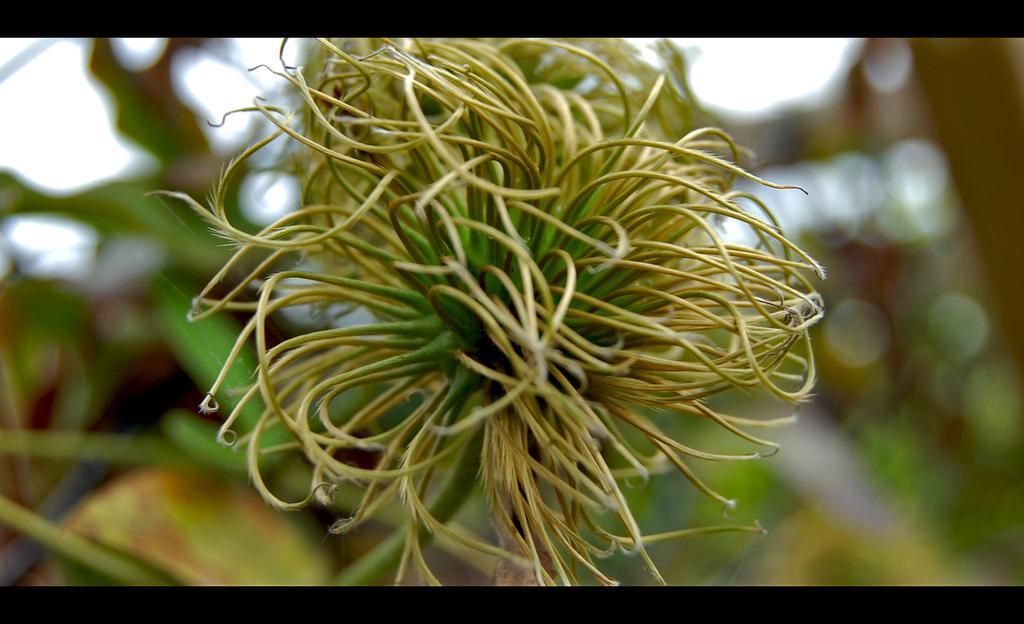In one or two sentences, can you explain what this image depicts? In this picture, it seems like a plant and the background is blurry. 